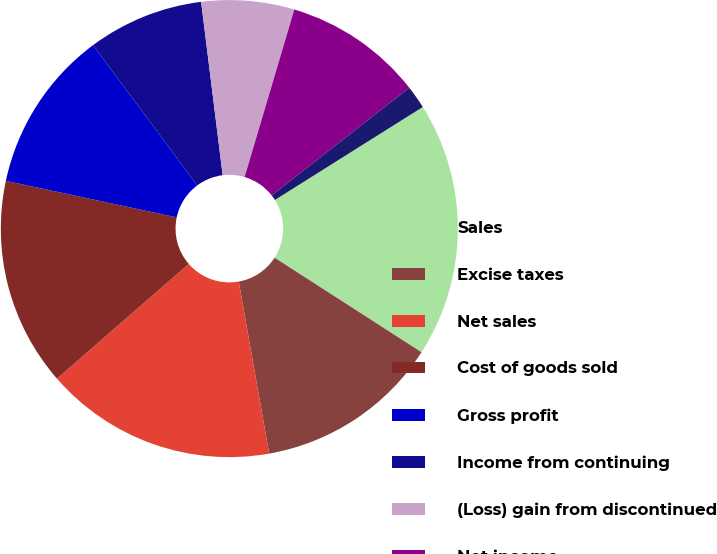Convert chart. <chart><loc_0><loc_0><loc_500><loc_500><pie_chart><fcel>Sales<fcel>Excise taxes<fcel>Net sales<fcel>Cost of goods sold<fcel>Gross profit<fcel>Income from continuing<fcel>(Loss) gain from discontinued<fcel>Net income<fcel>From continuing operations<fcel>From discontinued operations<nl><fcel>18.03%<fcel>13.11%<fcel>16.39%<fcel>14.75%<fcel>11.48%<fcel>8.2%<fcel>6.56%<fcel>9.84%<fcel>1.64%<fcel>0.0%<nl></chart> 